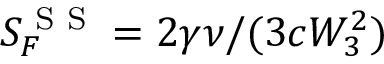Convert formula to latex. <formula><loc_0><loc_0><loc_500><loc_500>S _ { F } ^ { S S } = 2 \gamma \nu / ( 3 c W _ { 3 } ^ { 2 } )</formula> 